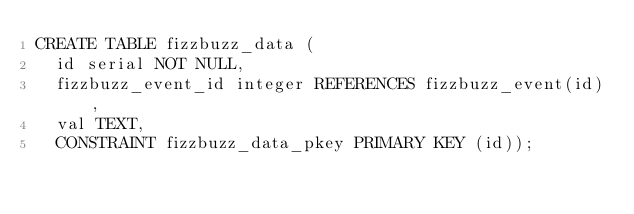Convert code to text. <code><loc_0><loc_0><loc_500><loc_500><_SQL_>CREATE TABLE fizzbuzz_data (
  id serial NOT NULL,
  fizzbuzz_event_id integer REFERENCES fizzbuzz_event(id),
  val TEXT,
  CONSTRAINT fizzbuzz_data_pkey PRIMARY KEY (id));
</code> 